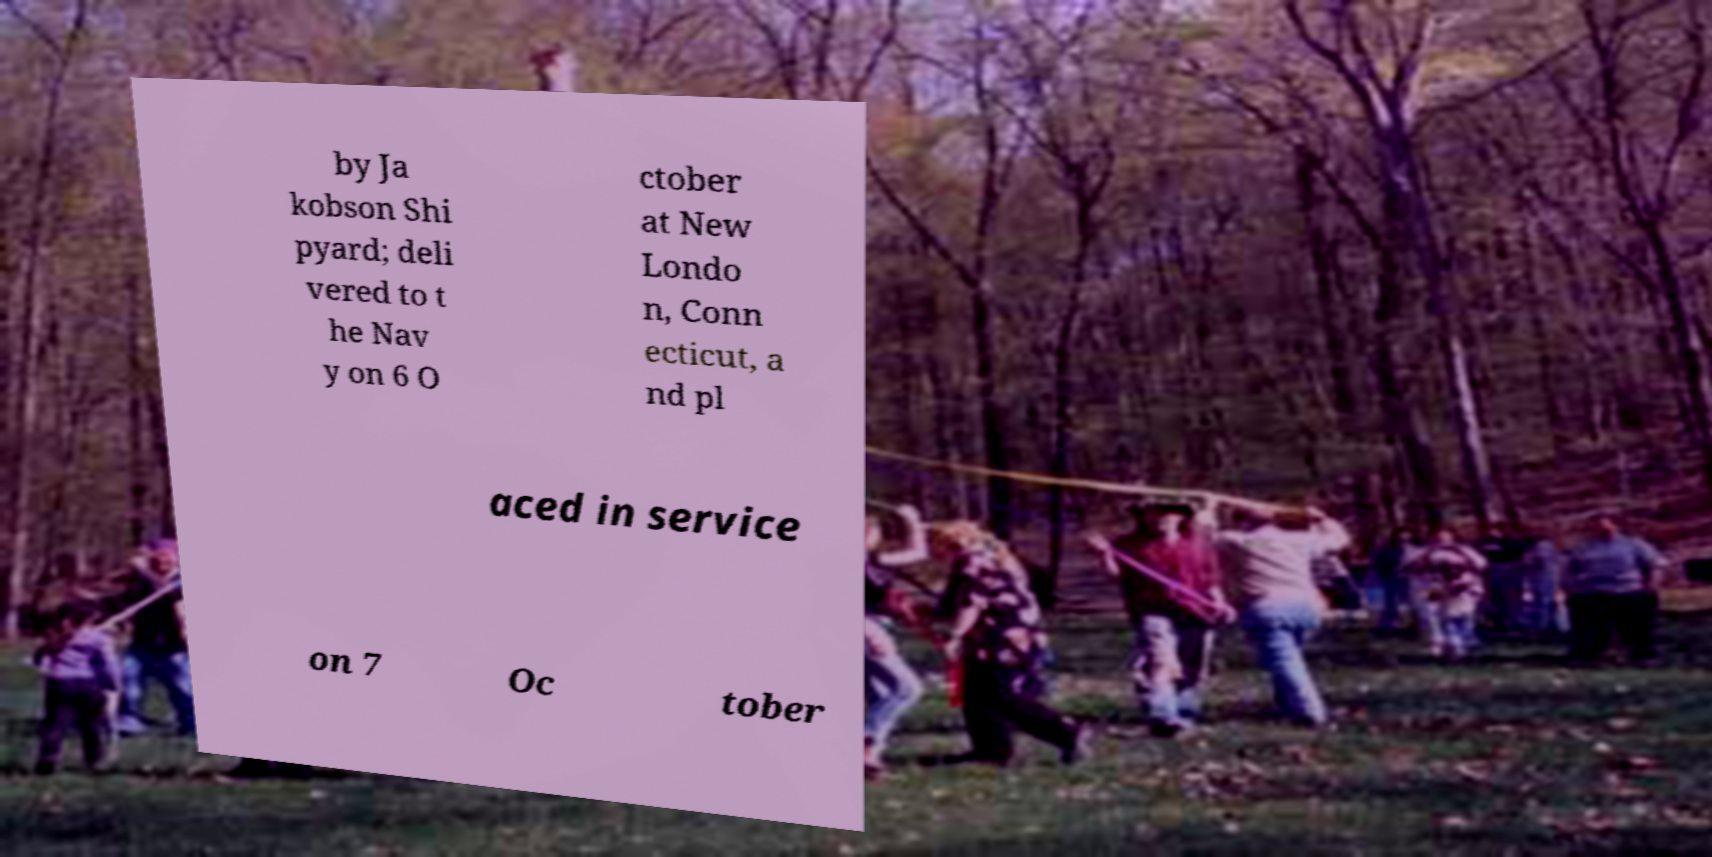There's text embedded in this image that I need extracted. Can you transcribe it verbatim? by Ja kobson Shi pyard; deli vered to t he Nav y on 6 O ctober at New Londo n, Conn ecticut, a nd pl aced in service on 7 Oc tober 